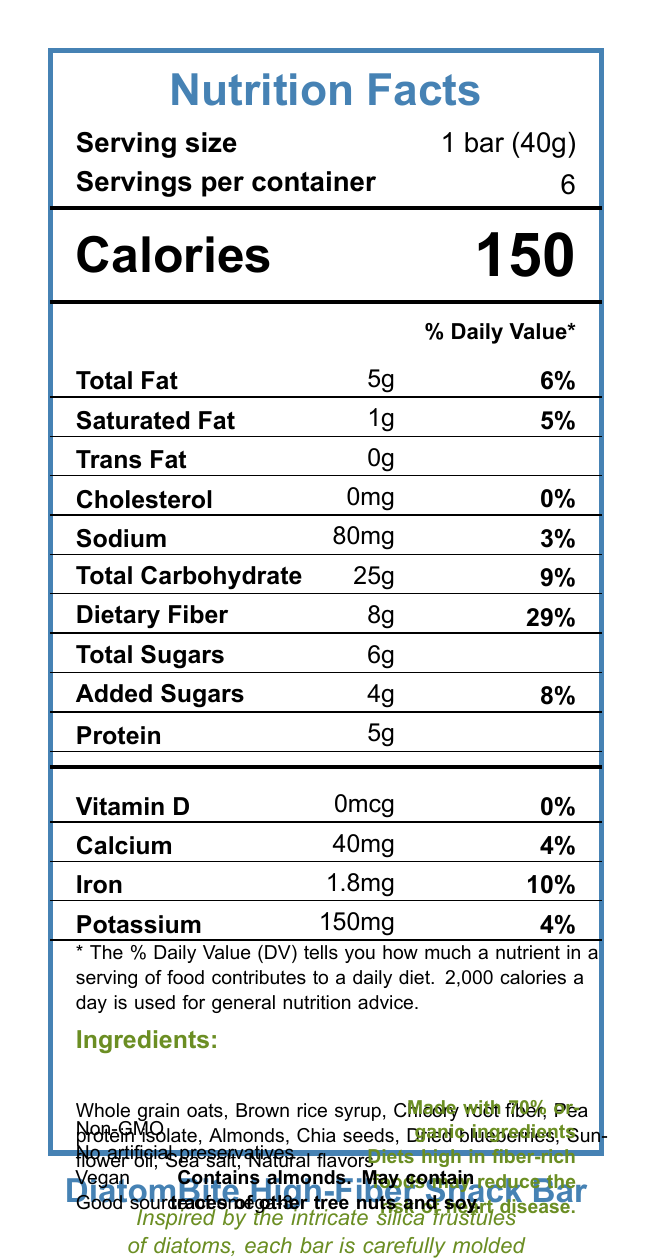what is the serving size for DiatomBite High-Fiber Snack Bar? The serving size information is listed at the top of the document.
Answer: 1 bar (40g) how many servings are in each container? The label specifies there are 6 servings per container.
Answer: 6 what is the total fat content per serving? The nutrient section lists 5g of total fat per serving.
Answer: 5g what is the percentage of the daily value for dietary fiber per serving? The nutrient section shows 29% daily value for dietary fiber.
Answer: 29% how much calcium does a DiatomBite High-Fiber Snack Bar contain? The vitamins and minerals section lists the calcium content as 40mg.
Answer: 40mg which nutrient shows a value of 3% daily value? A. Sodium B. Total Sugars C. Protein D. Cholesterol Sodium has a daily value percentage of 3% as shown in the nutrient section.
Answer: A. Sodium how much protein is in one serving of the snack bar? A. 5g B. 10g C. 15g D. 20g The nutrient section lists 5g of protein per serving.
Answer: A. 5g is the product vegan? The additional information section indicates that the product is vegan.
Answer: Yes is there any trans fat in the DiatomBite High-Fiber Snack Bar? The document lists trans fat as 0g.
Answer: No summarize the main idea of the document. The label provides comprehensive nutritional data, highlights special ingredients and health benefits, and gives background on the inspiration for the product shape.
Answer: The document is a Nutrition Facts Label for a DiatomBite High-Fiber Snack Bar, detailing calorie and nutrient information, ingredients, allergen information, and additional product features like being vegan and non-GMO. The bar is inspired by the forms of diatoms with a high fiber content claimed to reduce the risk of heart disease. what percentage of the ingredients are organic? The organic statement specifies that the bar is made with 70% organic ingredients.
Answer: 70% are there artificial preservatives in the DiatomBite High-Fiber Snack Bar? The additional information section includes the statement "No artificial preservatives".
Answer: No what is the sculptor's inspiration for the design of the snack bar? The sculptor note explains that the design is inspired by the intricate silica frustules of diatoms.
Answer: Diatoms does this product contain any cholesterol? The nutrient section shows that cholesterol is 0mg, meaning there is no cholesterol in the product.
Answer: No can you determine the price of the snack bar from this document? The document does not include pricing information; it only provides nutritional details and product features.
Answer: Not enough information 